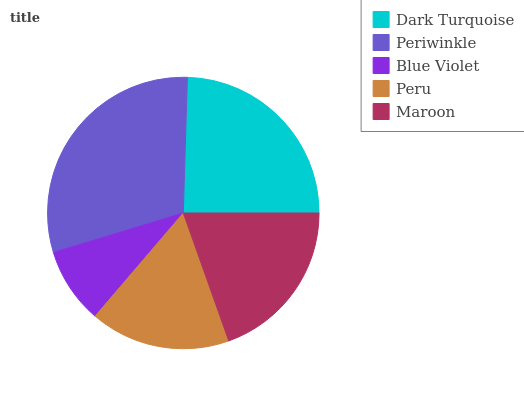Is Blue Violet the minimum?
Answer yes or no. Yes. Is Periwinkle the maximum?
Answer yes or no. Yes. Is Periwinkle the minimum?
Answer yes or no. No. Is Blue Violet the maximum?
Answer yes or no. No. Is Periwinkle greater than Blue Violet?
Answer yes or no. Yes. Is Blue Violet less than Periwinkle?
Answer yes or no. Yes. Is Blue Violet greater than Periwinkle?
Answer yes or no. No. Is Periwinkle less than Blue Violet?
Answer yes or no. No. Is Maroon the high median?
Answer yes or no. Yes. Is Maroon the low median?
Answer yes or no. Yes. Is Periwinkle the high median?
Answer yes or no. No. Is Peru the low median?
Answer yes or no. No. 